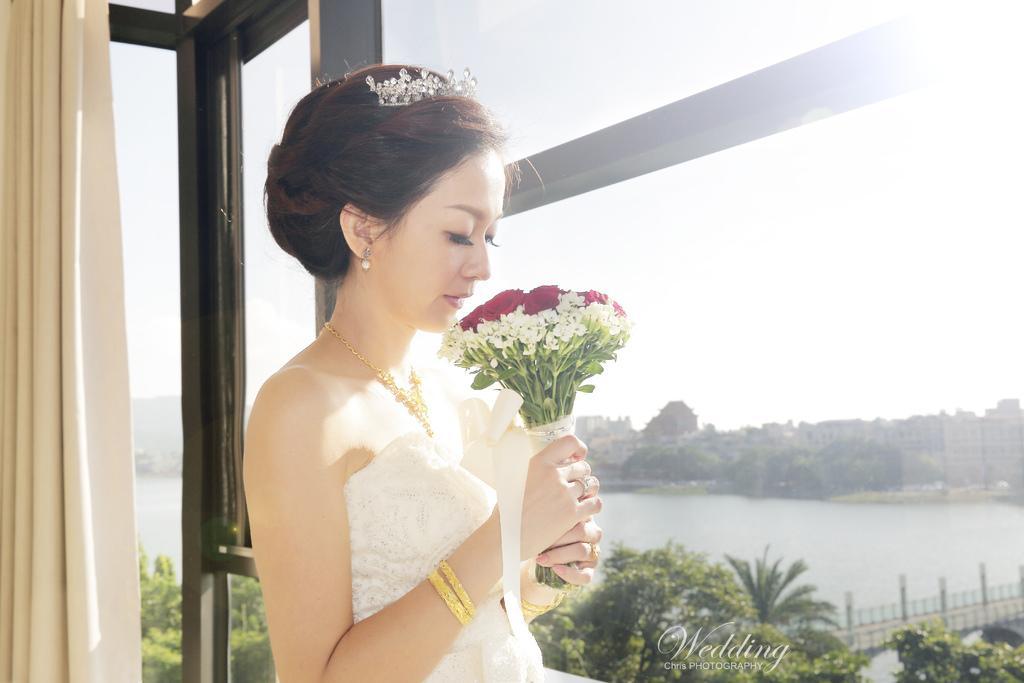How would you summarize this image in a sentence or two? In this picture we can see a woman holding a flower bouquet with her hands, curtain and in the background we can see buildings, trees, fence, sky. 